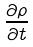<formula> <loc_0><loc_0><loc_500><loc_500>\frac { \partial \rho } { \partial t }</formula> 